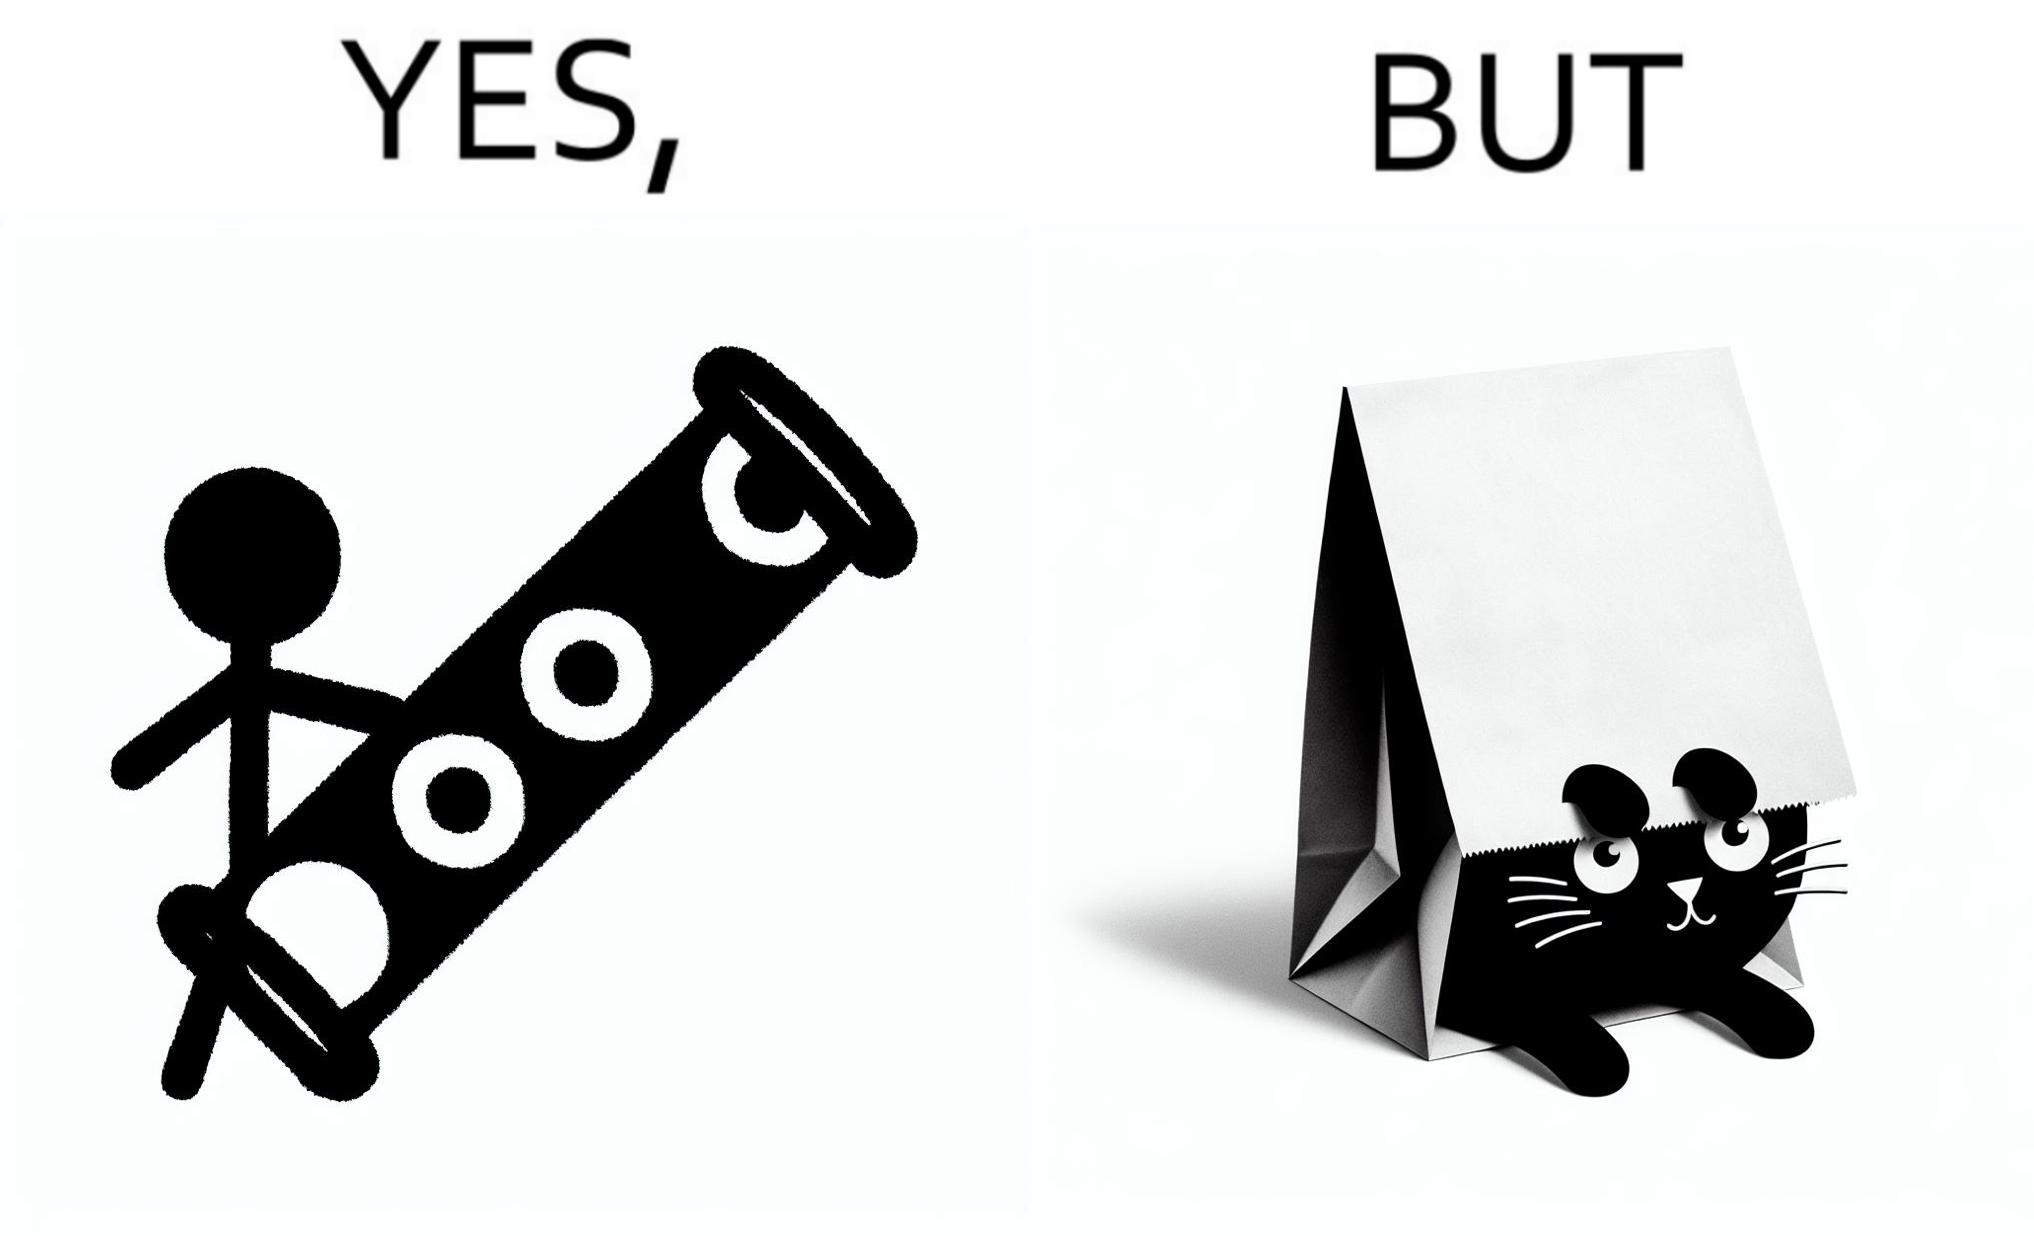Describe the contrast between the left and right parts of this image. In the left part of the image: a long piece of cylinder with two circular holes over its surface and two holes at top and bottom and a hanging toy at one end In the right part of the image: an animal hiding its face in a paper bag, probably a cat or dog 